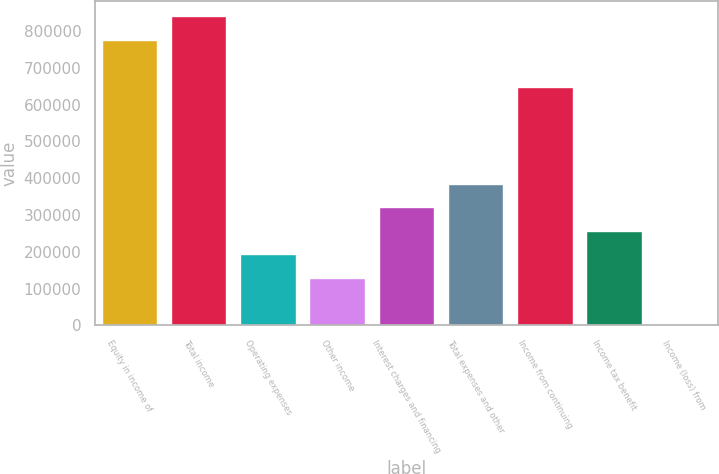<chart> <loc_0><loc_0><loc_500><loc_500><bar_chart><fcel>Equity in income of<fcel>Total income<fcel>Operating expenses<fcel>Other income<fcel>Interest charges and financing<fcel>Total expenses and other<fcel>Income from continuing<fcel>Income tax benefit<fcel>Income (loss) from<nl><fcel>775525<fcel>839394<fcel>193056<fcel>129187<fcel>320794<fcel>384664<fcel>647787<fcel>256925<fcel>1449<nl></chart> 